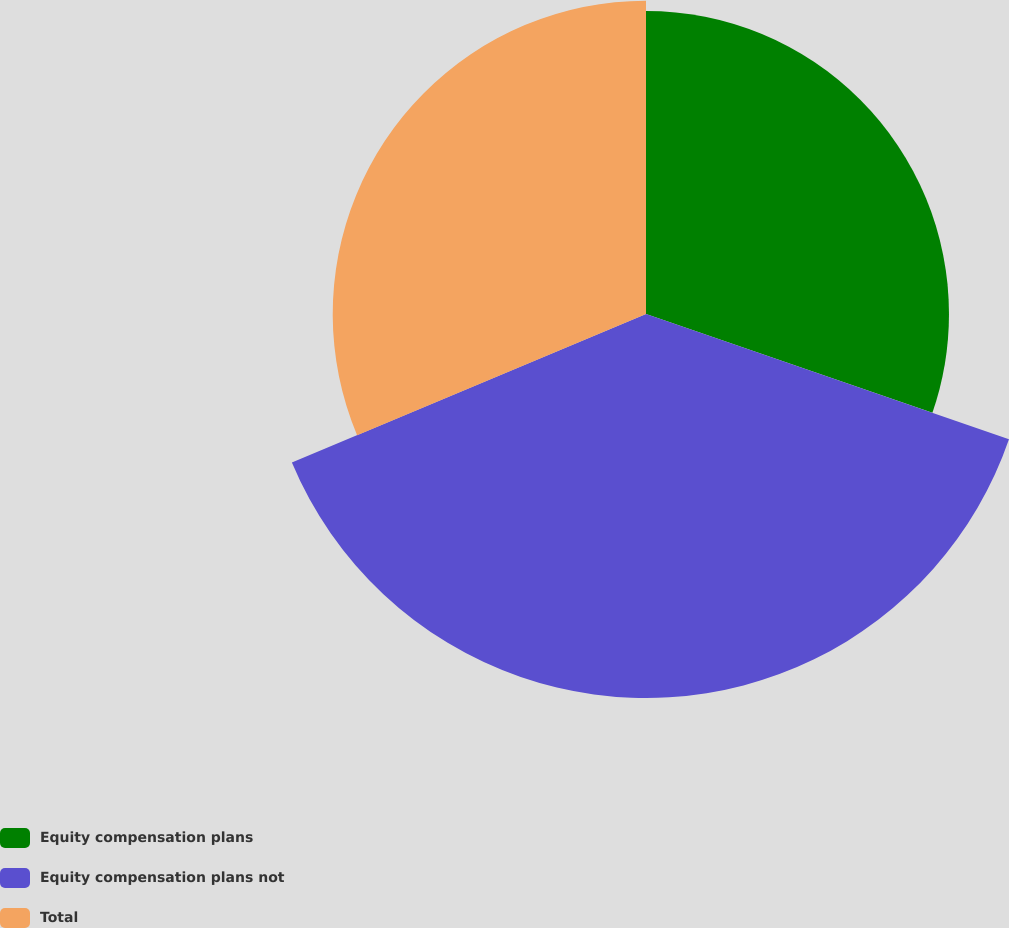<chart> <loc_0><loc_0><loc_500><loc_500><pie_chart><fcel>Equity compensation plans<fcel>Equity compensation plans not<fcel>Total<nl><fcel>30.29%<fcel>38.39%<fcel>31.32%<nl></chart> 